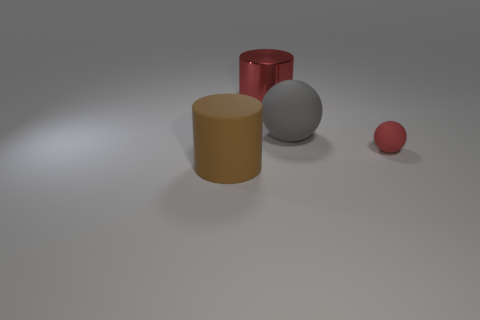There is a cylinder left of the red cylinder; how big is it?
Keep it short and to the point. Large. The cylinder that is behind the large object in front of the red matte ball that is right of the big brown object is what color?
Keep it short and to the point. Red. What is the color of the large cylinder in front of the large rubber object on the right side of the brown cylinder?
Provide a short and direct response. Brown. Is the number of red cylinders that are in front of the big brown cylinder greater than the number of red rubber spheres to the left of the red ball?
Provide a short and direct response. No. Is the red object that is behind the tiny object made of the same material as the ball right of the big gray ball?
Offer a terse response. No. There is a big gray sphere; are there any red matte things in front of it?
Give a very brief answer. Yes. What number of green things are either cylinders or big spheres?
Provide a short and direct response. 0. Do the big red cylinder and the large object that is in front of the small red object have the same material?
Give a very brief answer. No. What size is the red matte thing that is the same shape as the big gray object?
Provide a succinct answer. Small. What is the large red object made of?
Offer a very short reply. Metal. 